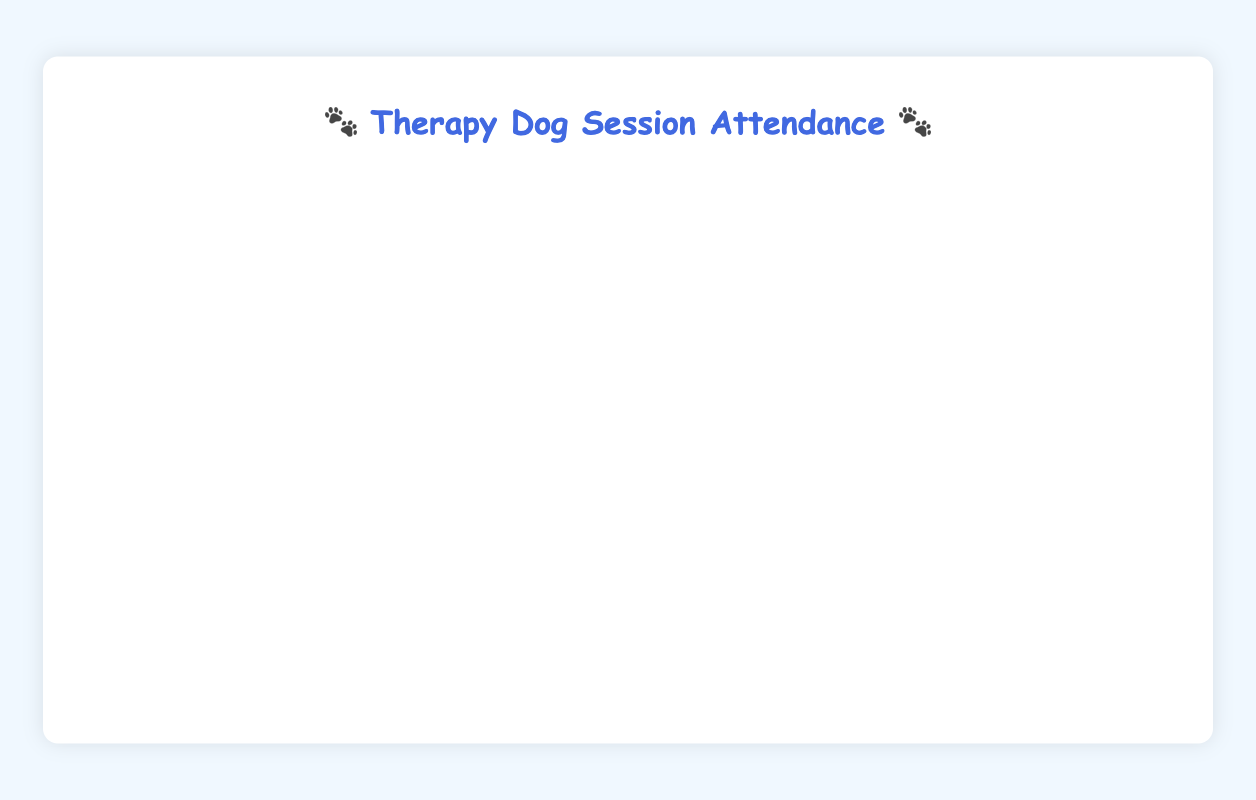How many weeks had exactly 80 students attending the therapy dog sessions? Look for peak values in the 'Total Students' line at 80 and count the instances. These occur on 2022-10-31, 2023-02-06, and 2023-03-27.
Answer: 3 What is the highest number of sessions held in a week and in which weeks did it occur? Look for peak values in the 'Sessions' line and identify the corresponding weeks. The peak is 5 sessions, occurring in 2022-10-03, 2022-10-10, 2022-10-31, 2022-12-12, 2023-01-23, 2023-02-06, 2023-03-06, 2023-03-27, 2023-04-24, and 2023-05-15.
Answer: 10 weeks During which quarter did the total students number stay consistently above 60? Divide the year into quarters and inspect the 'Total Students' line. In Q2 2023, weekly attendance consistently stays above 60, as observed from weeks 2023-04-03 to 2023-06-19.
Answer: Q2 2023 Which week had the lowest total number of students attending, and what was that number? Identify the minimum value in the 'Total Students' line and determine the corresponding week. The lowest attendance was 35 students in the week 2022-11-21.
Answer: 2022-11-21 How does the highest attendance compare in terms of the week with the most sessions? Check if the week with the highest attendance also had the most sessions and compare if they align. 2023-05-15 had the highest attendance with 85 students, which also had 5 sessions.
Answer: They align What is the average number of students attending per week across the entire academic year? Sum the total number of students from all weeks and divide by the number of weeks (average). The total is 2045 students over 38 weeks, so the average is 2045/38 ≈ 53.82.
Answer: 53.82 How many weeks had more than 4 sessions and more than 60 students attending? Identify weeks where both conditions are met by checking the corresponding values on the 'Sessions' and 'Total Students' lines. These are weeks in 2023-02-06 and 2023-03-27.
Answer: 2 When the number of sessions dropped to 2, how many students attended that week? Locate the week with 2 sessions on the 'Sessions' line and find the corresponding 'Total Students' value. On 2022-11-21, the number of sessions dropped to 2 with 35 students attending.
Answer: 35 During which weeks did the number of sessions and total student attendance both hit their peaks? Examine weeks where both 'Sessions' and 'Total Students' lines are at their maximum. This occurs in the week 2023-05-15 with 5 sessions and 85 students.
Answer: 2023-05-15 Which quarter showed the most variable student attendance? Analyze attendance trends across each quarter and identify the one with the highest variability (spread between the highest and lowest attendance). Q1 2023 (January to March) shows high variability with a range from 40 to 80 students.
Answer: Q1 2023 